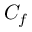<formula> <loc_0><loc_0><loc_500><loc_500>C _ { f }</formula> 